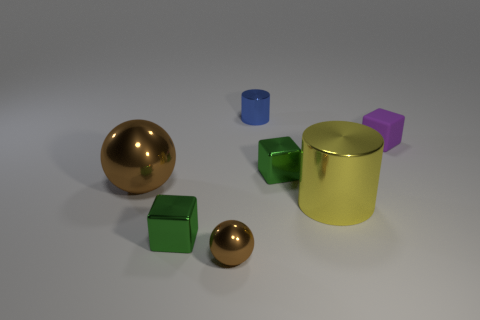Subtract all cylinders. How many objects are left? 5 Add 1 brown metal things. How many objects exist? 8 Add 4 blue objects. How many blue objects are left? 5 Add 3 small purple shiny cylinders. How many small purple shiny cylinders exist? 3 Subtract 0 brown cylinders. How many objects are left? 7 Subtract all small brown cylinders. Subtract all big brown balls. How many objects are left? 6 